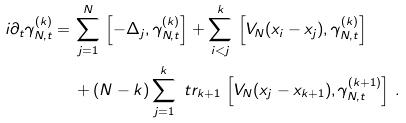<formula> <loc_0><loc_0><loc_500><loc_500>i \partial _ { t } \gamma ^ { ( k ) } _ { N , t } = \, & \sum _ { j = 1 } ^ { N } \, \left [ - \Delta _ { j } , \gamma ^ { ( k ) } _ { N , t } \right ] + \sum _ { i < j } ^ { k } \, \left [ V _ { N } ( x _ { i } - x _ { j } ) , \gamma ^ { ( k ) } _ { N , t } \right ] \\ & + ( N - k ) \sum _ { j = 1 } ^ { k } \ t r _ { k + 1 } \, \left [ V _ { N } ( x _ { j } - x _ { k + 1 } ) , \gamma ^ { ( k + 1 ) } _ { N , t } \right ] \, .</formula> 